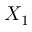Convert formula to latex. <formula><loc_0><loc_0><loc_500><loc_500>X _ { 1 }</formula> 